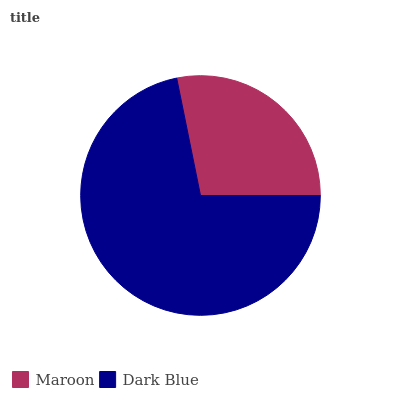Is Maroon the minimum?
Answer yes or no. Yes. Is Dark Blue the maximum?
Answer yes or no. Yes. Is Dark Blue the minimum?
Answer yes or no. No. Is Dark Blue greater than Maroon?
Answer yes or no. Yes. Is Maroon less than Dark Blue?
Answer yes or no. Yes. Is Maroon greater than Dark Blue?
Answer yes or no. No. Is Dark Blue less than Maroon?
Answer yes or no. No. Is Dark Blue the high median?
Answer yes or no. Yes. Is Maroon the low median?
Answer yes or no. Yes. Is Maroon the high median?
Answer yes or no. No. Is Dark Blue the low median?
Answer yes or no. No. 